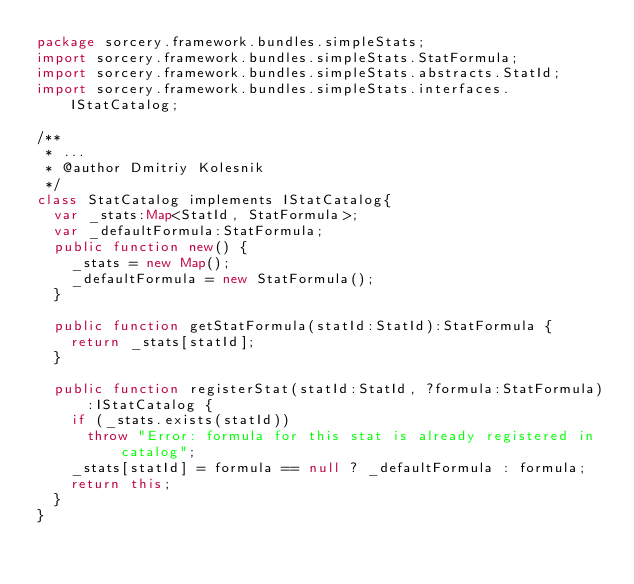Convert code to text. <code><loc_0><loc_0><loc_500><loc_500><_Haxe_>package sorcery.framework.bundles.simpleStats;
import sorcery.framework.bundles.simpleStats.StatFormula;
import sorcery.framework.bundles.simpleStats.abstracts.StatId;
import sorcery.framework.bundles.simpleStats.interfaces.IStatCatalog;

/**
 * ...
 * @author Dmitriy Kolesnik
 */
class StatCatalog implements IStatCatalog{
	var _stats:Map<StatId, StatFormula>;
	var _defaultFormula:StatFormula;
	public function new() {
		_stats = new Map();
		_defaultFormula = new StatFormula();
	}
	
	public function getStatFormula(statId:StatId):StatFormula {
		return _stats[statId];
	}
	
	public function registerStat(statId:StatId, ?formula:StatFormula):IStatCatalog {
		if (_stats.exists(statId))
			throw "Error: formula for this stat is already registered in catalog";
		_stats[statId] = formula == null ? _defaultFormula : formula;
		return this;
	}
}</code> 